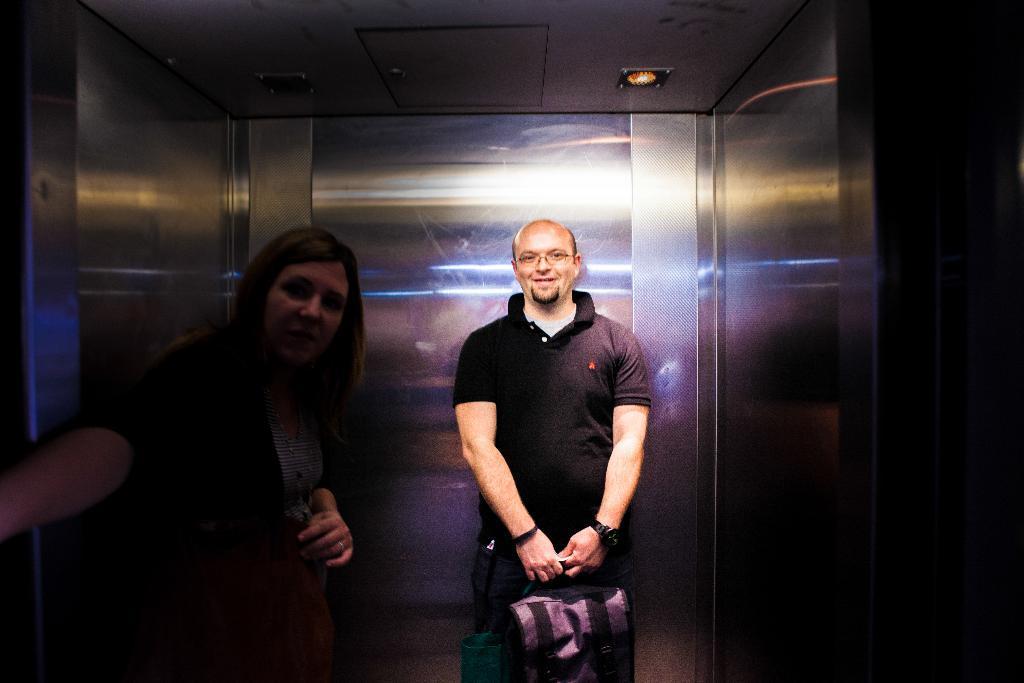In one or two sentences, can you explain what this image depicts? In this image there are two people in the lift in which one of them holds the bags, there are lights at the top and reflections of lights on the wall of the lift. 